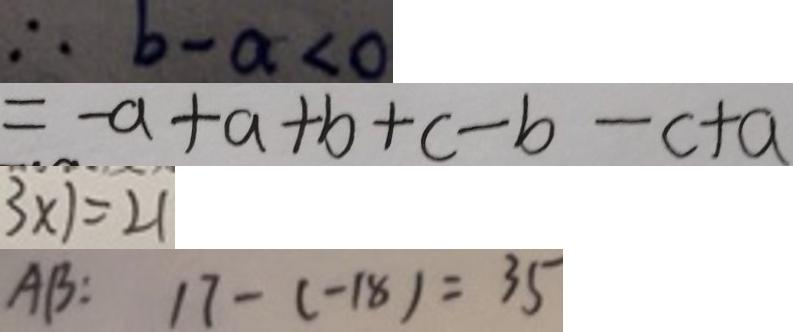Convert formula to latex. <formula><loc_0><loc_0><loc_500><loc_500>\therefore b - a < 0 
 = - a + a + b + c - b - c + a 
 3 \times 7 = 2 1 
 A B : 1 7 - ( - 1 8 ) = 3 5</formula> 